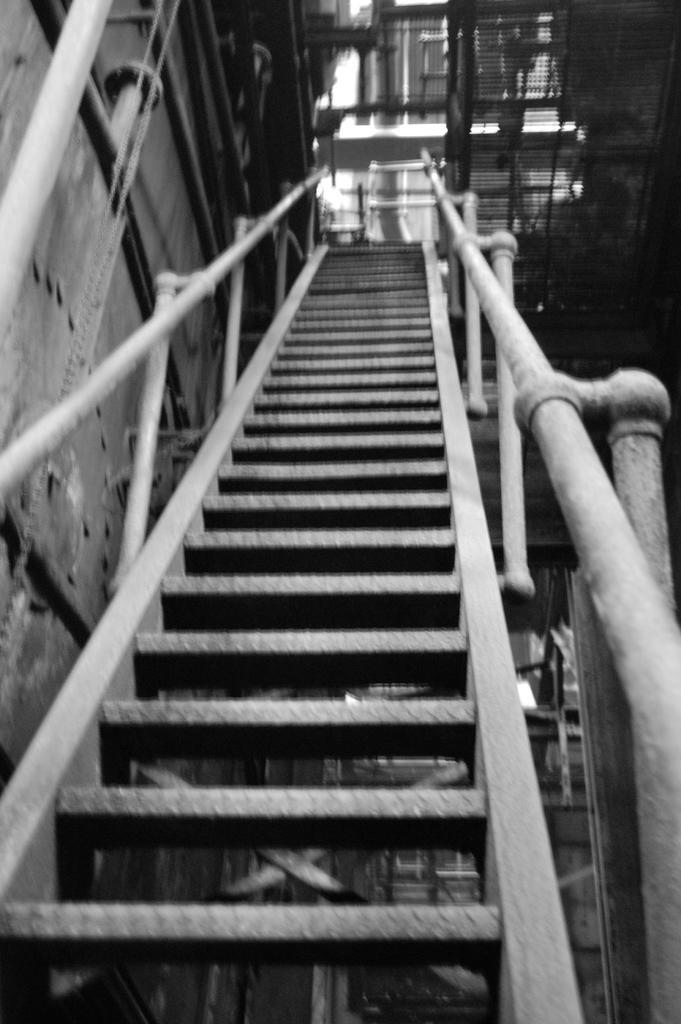Please provide a concise description of this image. In this image we can see staircase, poles, buildings, and the picture is taken in black and white mode. 